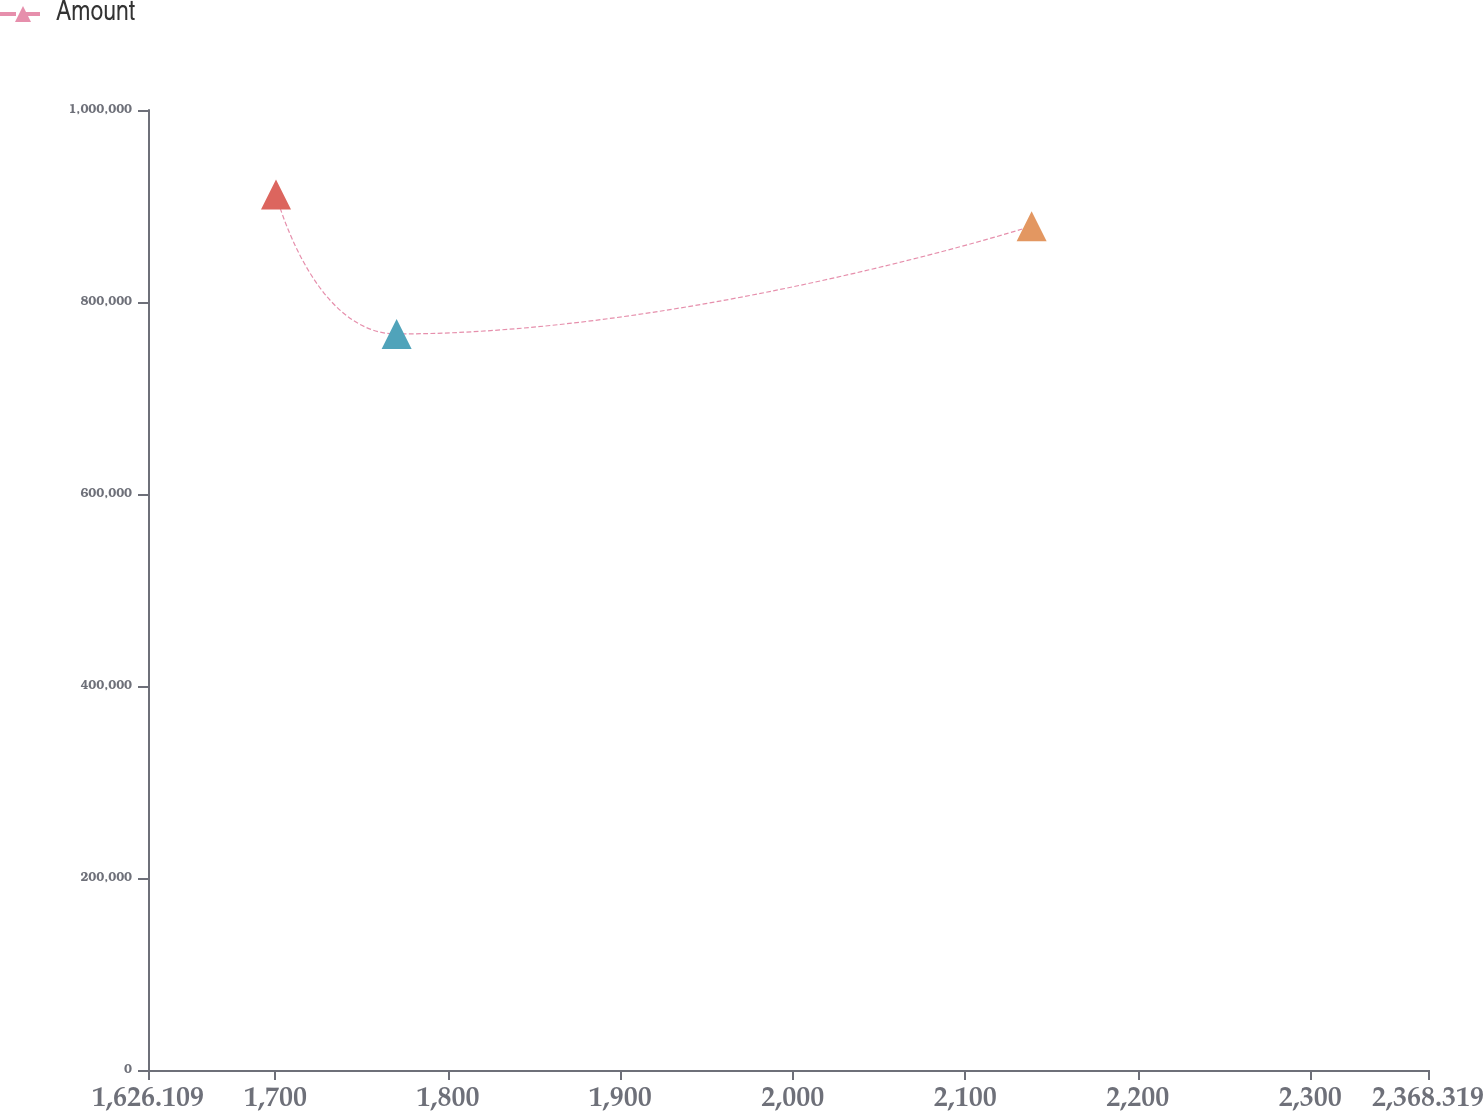Convert chart. <chart><loc_0><loc_0><loc_500><loc_500><line_chart><ecel><fcel>Amount<nl><fcel>1700.33<fcel>911945<nl><fcel>1770.29<fcel>766712<nl><fcel>2138.48<fcel>878986<nl><fcel>2372.58<fcel>927206<nl><fcel>2442.54<fcel>783659<nl></chart> 